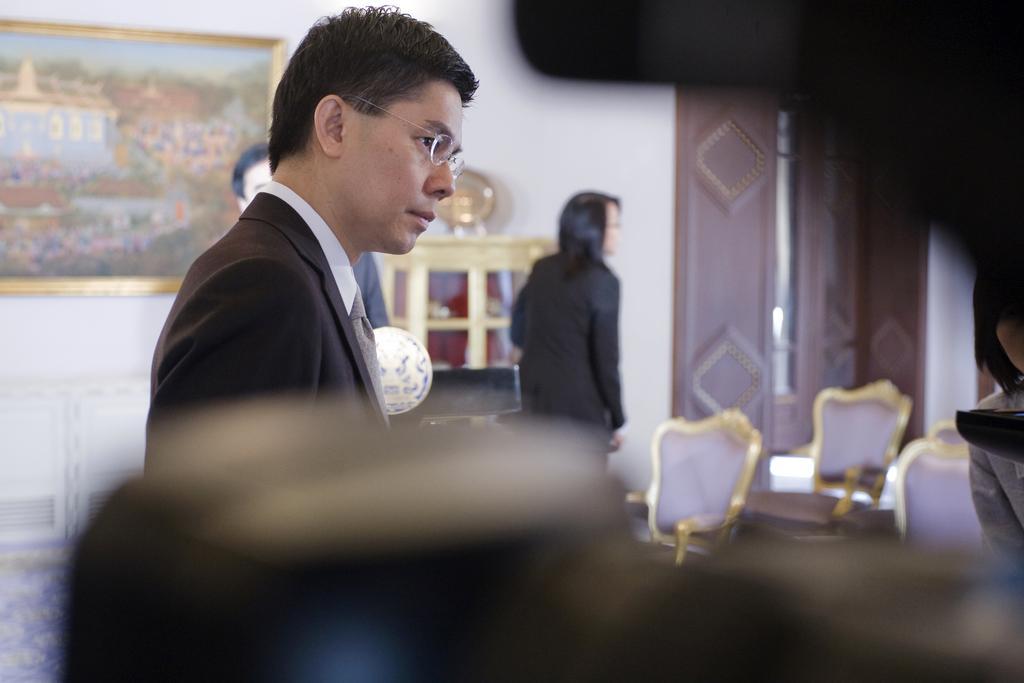Can you describe this image briefly? In this image there is a person standing with black suit and spectacles. At the right side of the image there are chairs and curtain, at the left side of the image there is a painting on the wall and two other persons standing at the back of the image. 